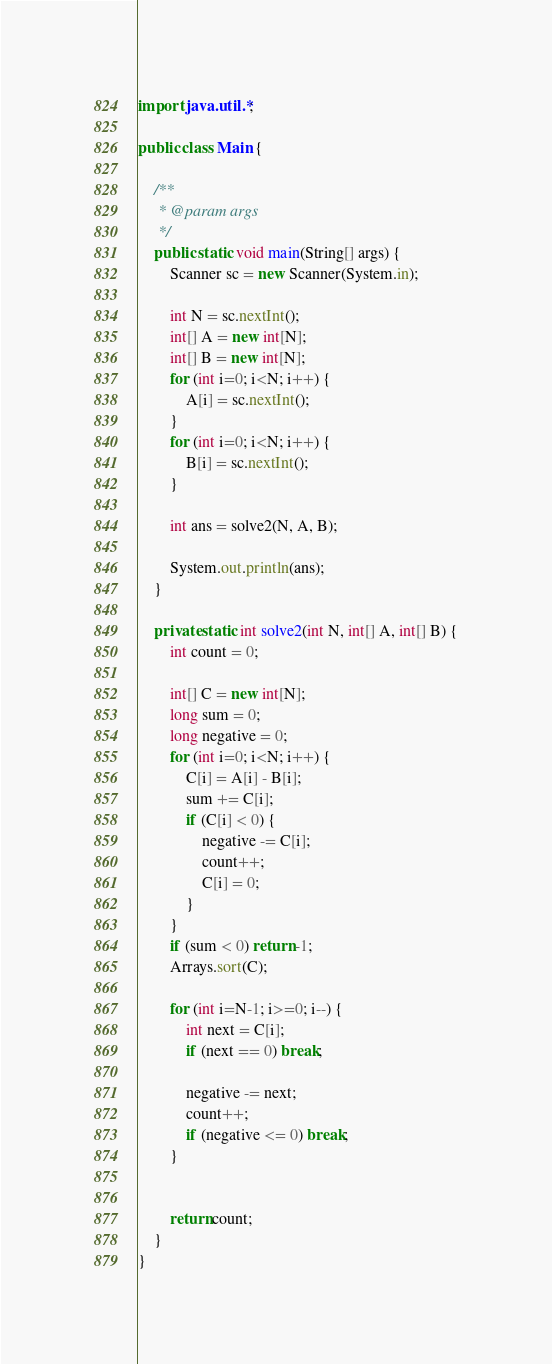Convert code to text. <code><loc_0><loc_0><loc_500><loc_500><_Java_>import java.util.*;

public class Main {

    /**
     * @param args
     */
    public static void main(String[] args) {
        Scanner sc = new Scanner(System.in);

        int N = sc.nextInt();
        int[] A = new int[N];
        int[] B = new int[N];
        for (int i=0; i<N; i++) {
            A[i] = sc.nextInt();
        }
        for (int i=0; i<N; i++) {
            B[i] = sc.nextInt();
        }

        int ans = solve2(N, A, B);

        System.out.println(ans);
    }

    private static int solve2(int N, int[] A, int[] B) {
        int count = 0;

        int[] C = new int[N];
        long sum = 0;
        long negative = 0;
        for (int i=0; i<N; i++) {
            C[i] = A[i] - B[i];
            sum += C[i];
            if (C[i] < 0) {
                negative -= C[i];
                count++;
                C[i] = 0;
            }
        }
        if (sum < 0) return -1;
        Arrays.sort(C);

        for (int i=N-1; i>=0; i--) {
            int next = C[i];
            if (next == 0) break;

            negative -= next;
            count++;
            if (negative <= 0) break;
        }


        return count;
    }
}</code> 